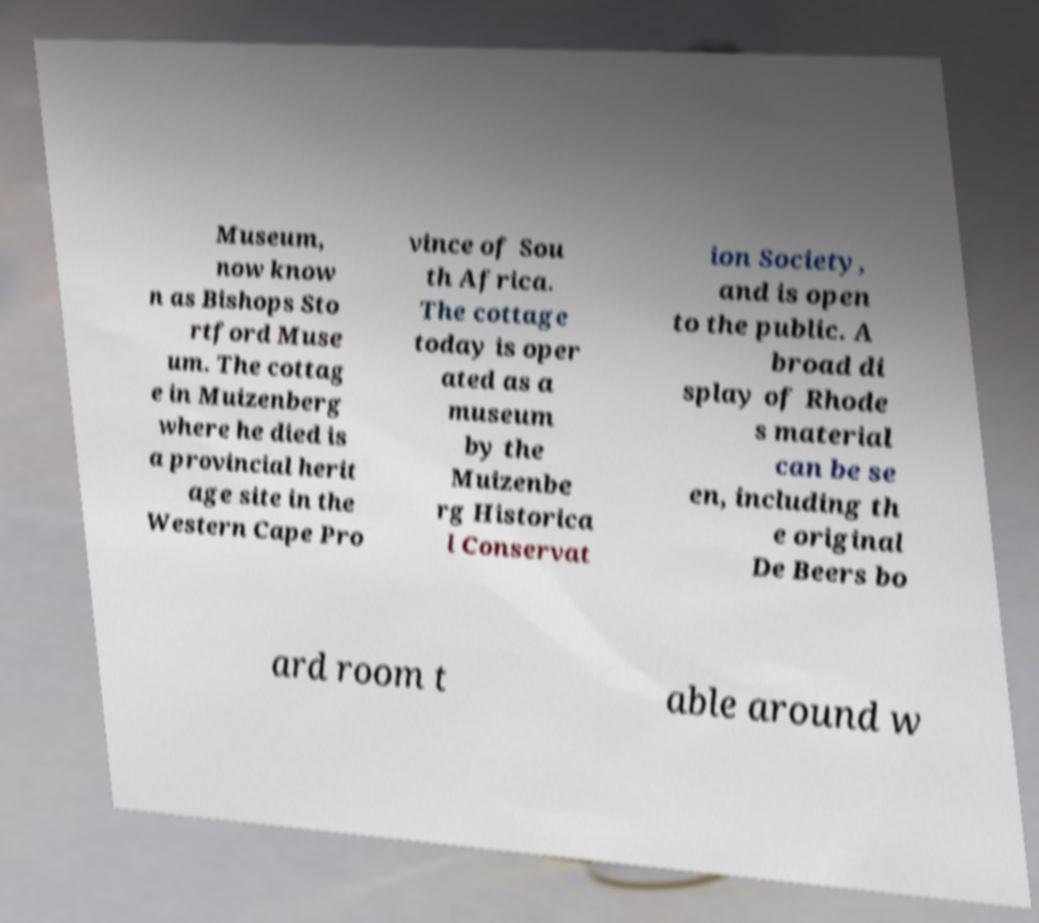For documentation purposes, I need the text within this image transcribed. Could you provide that? Museum, now know n as Bishops Sto rtford Muse um. The cottag e in Muizenberg where he died is a provincial herit age site in the Western Cape Pro vince of Sou th Africa. The cottage today is oper ated as a museum by the Muizenbe rg Historica l Conservat ion Society, and is open to the public. A broad di splay of Rhode s material can be se en, including th e original De Beers bo ard room t able around w 